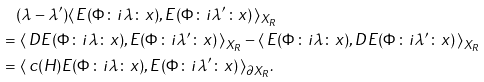<formula> <loc_0><loc_0><loc_500><loc_500>& ( \lambda - \lambda ^ { \prime } ) \langle \, E ( \Phi \colon i \lambda \colon x ) , E ( \Phi \colon i \lambda ^ { \prime } \colon x ) \, \rangle _ { X _ { R } } \\ = & \ \langle \, D E ( \Phi \colon i \lambda \colon x ) , E ( \Phi \colon i \lambda ^ { \prime } \colon x ) \, \rangle _ { X _ { R } } - \langle \, E ( \Phi \colon i \lambda \colon x ) , D E ( \Phi \colon i \lambda ^ { \prime } \colon x ) \, \rangle _ { X _ { R } } \\ = & \ \langle \, c ( H ) E ( \Phi \colon i \lambda \colon x ) , E ( \Phi \colon i \lambda ^ { \prime } \colon x ) \, \rangle _ { \partial X _ { R } } .</formula> 